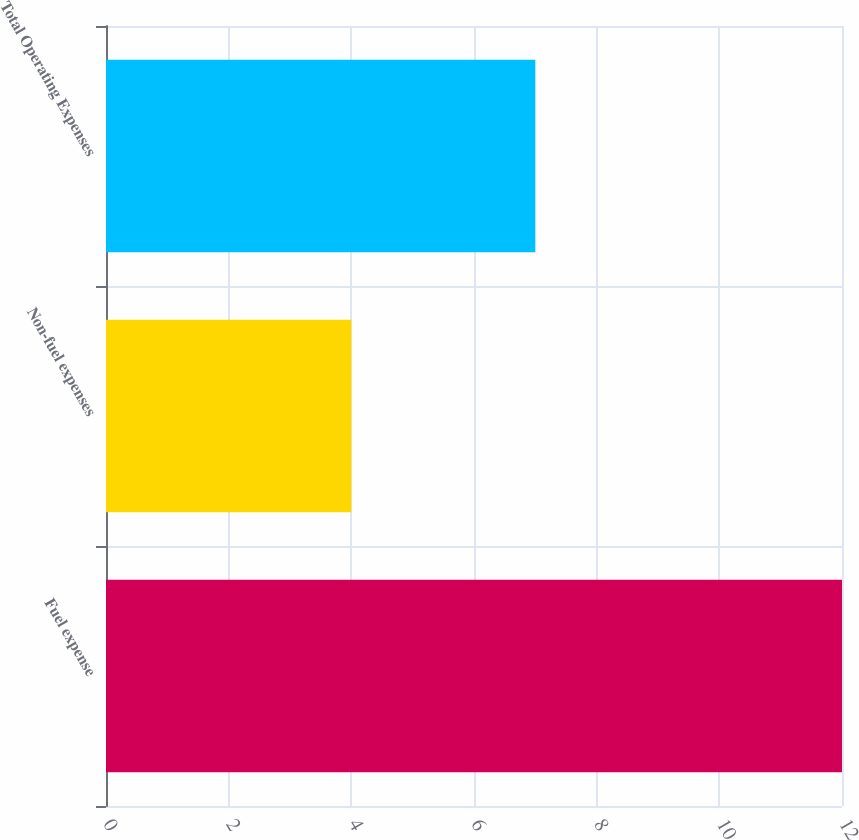Convert chart. <chart><loc_0><loc_0><loc_500><loc_500><bar_chart><fcel>Fuel expense<fcel>Non-fuel expenses<fcel>Total Operating Expenses<nl><fcel>12<fcel>4<fcel>7<nl></chart> 